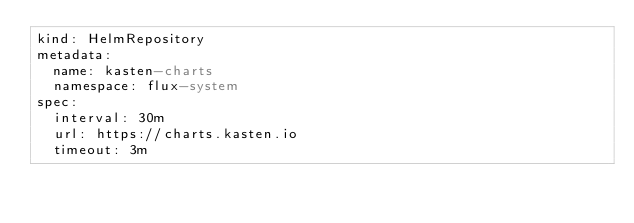Convert code to text. <code><loc_0><loc_0><loc_500><loc_500><_YAML_>kind: HelmRepository
metadata:
  name: kasten-charts
  namespace: flux-system
spec:
  interval: 30m
  url: https://charts.kasten.io
  timeout: 3m
</code> 